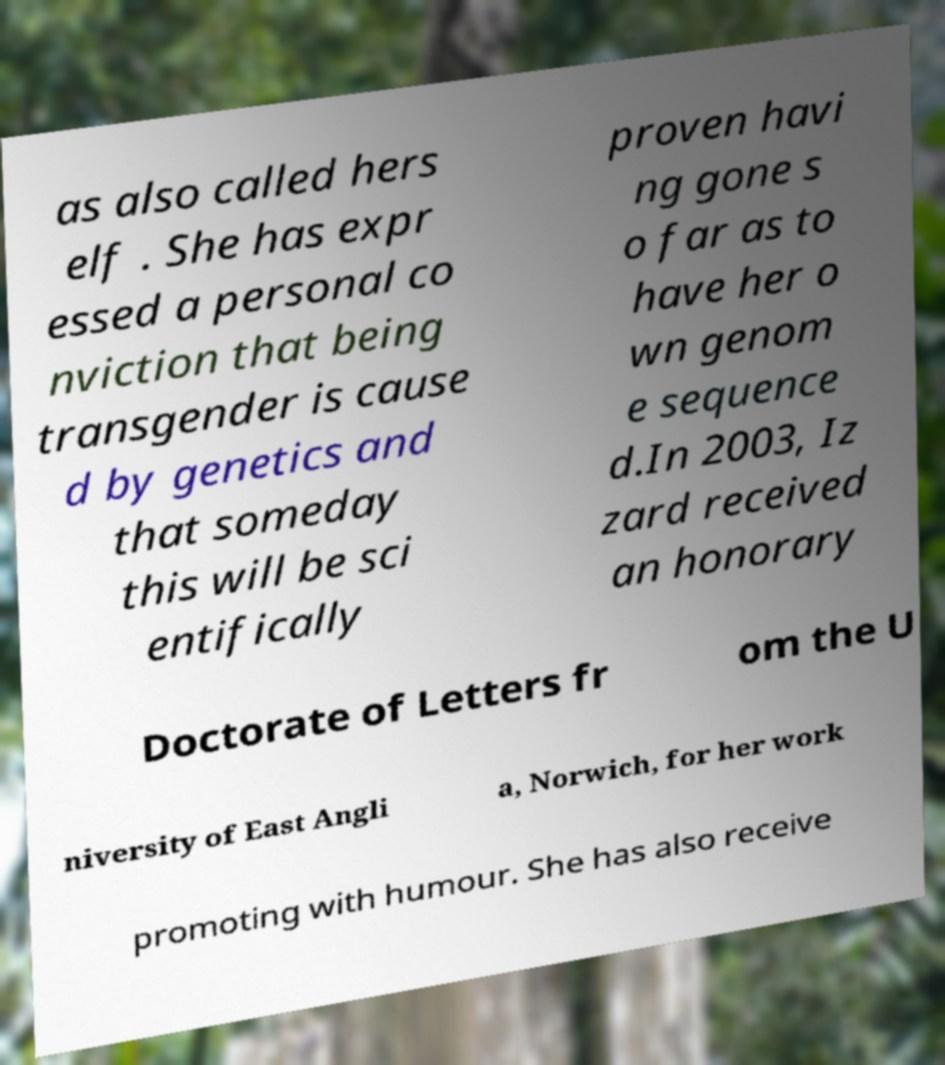What messages or text are displayed in this image? I need them in a readable, typed format. as also called hers elf . She has expr essed a personal co nviction that being transgender is cause d by genetics and that someday this will be sci entifically proven havi ng gone s o far as to have her o wn genom e sequence d.In 2003, Iz zard received an honorary Doctorate of Letters fr om the U niversity of East Angli a, Norwich, for her work promoting with humour. She has also receive 